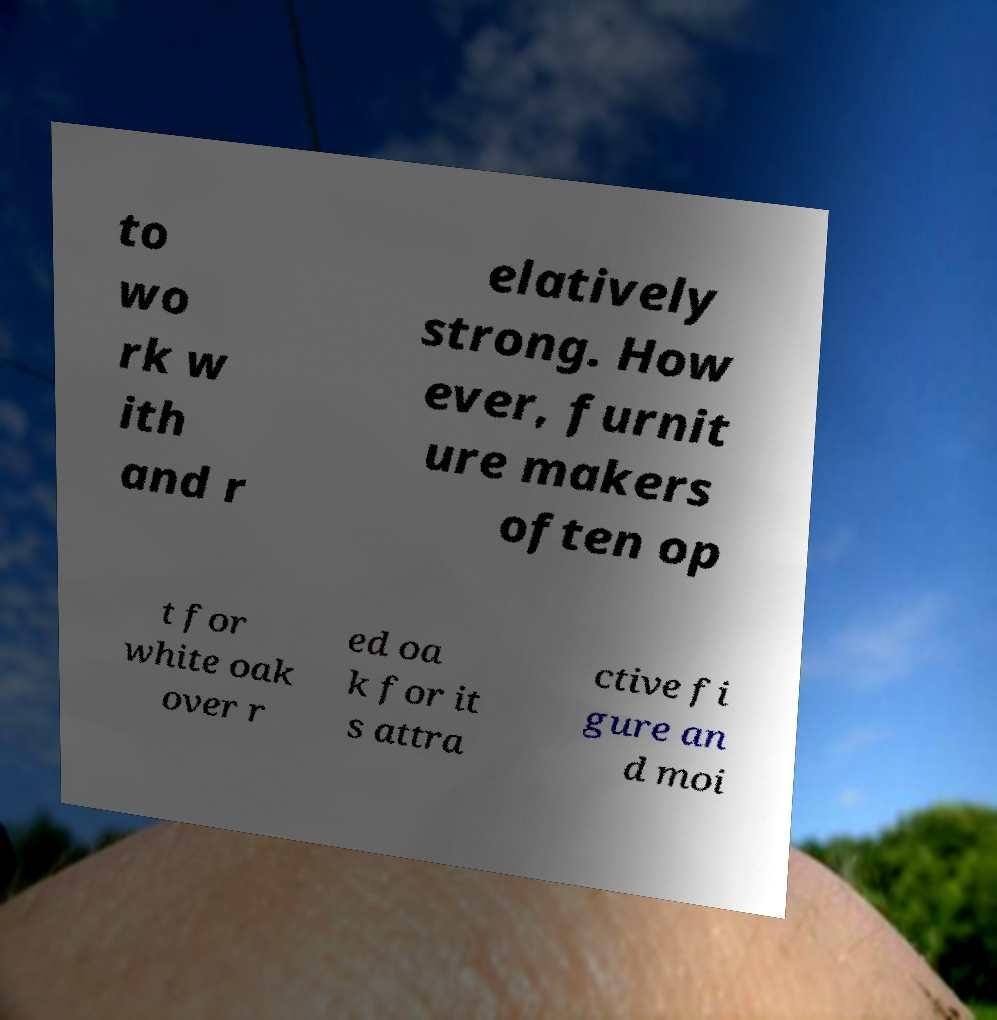Can you read and provide the text displayed in the image?This photo seems to have some interesting text. Can you extract and type it out for me? to wo rk w ith and r elatively strong. How ever, furnit ure makers often op t for white oak over r ed oa k for it s attra ctive fi gure an d moi 